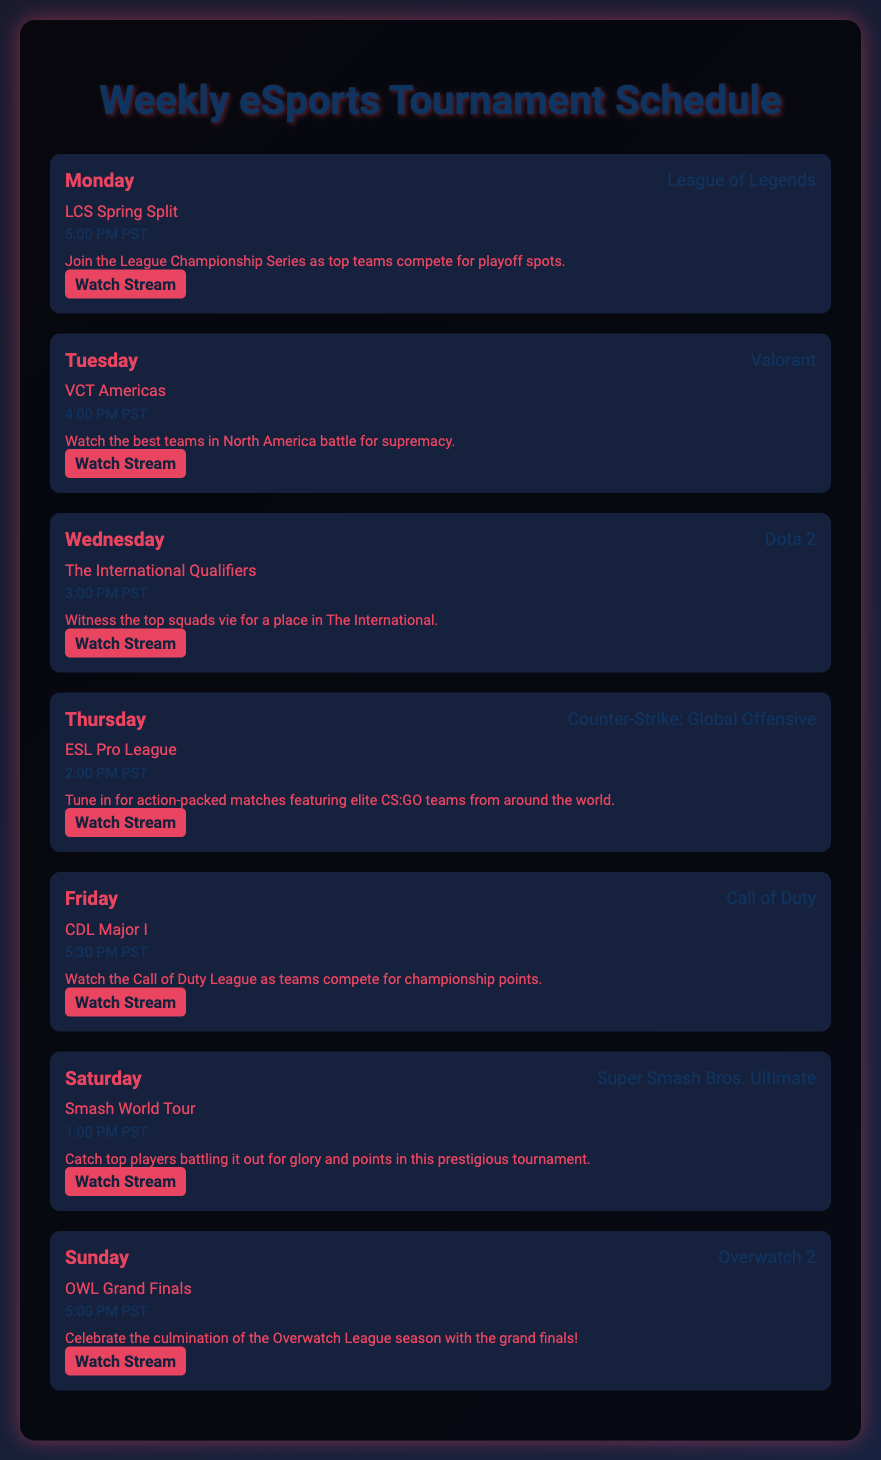What game is featured on Monday? The document lists "League of Legends" as the game for Monday.
Answer: League of Legends What time does the Friday tournament start? The document states that the CDL Major I tournament starts at 5:30 PM PST on Friday.
Answer: 5:30 PM PST Which tournament happens on Saturday? According to the document, the Smash World Tour takes place on Saturday.
Answer: Smash World Tour What team competition is occurring on Wednesday? The document mentions that "The International Qualifiers" for Dota 2 is the Wednesday tournament.
Answer: The International Qualifiers Which streaming link is associated with Counter-Strike: Global Offensive? The document provides a link to "https://www.twitch.tv/esl_csgo" for the ESL Pro League.
Answer: https://www.twitch.tv/esl_csgo How many games are scheduled for the weekend? The document indicates there are two games scheduled for the weekend, one on Saturday and one on Sunday.
Answer: 2 Which day features the Overwatch League Grand Finals? The document specifies that the OWL Grand Finals occurs on Sunday.
Answer: Sunday What is the main event on Tuesday? The document highlights "VCT Americas" as the main event on Tuesday.
Answer: VCT Americas What color is the background gradient of the document? The background gradient includes shades of deep blue and dark colors specified in the style.
Answer: #1a1a2e to #16213e 